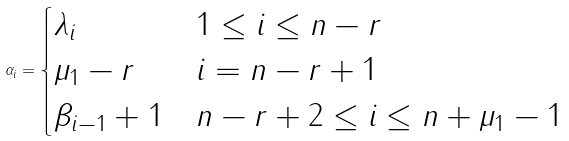<formula> <loc_0><loc_0><loc_500><loc_500>\alpha _ { i } = \begin{cases} \lambda _ { i } & 1 \leq i \leq n - r \\ \mu _ { 1 } - r & i = n - r + 1 \\ \beta _ { i - 1 } + 1 & n - r + 2 \leq i \leq n + \mu _ { 1 } - 1 \end{cases}</formula> 